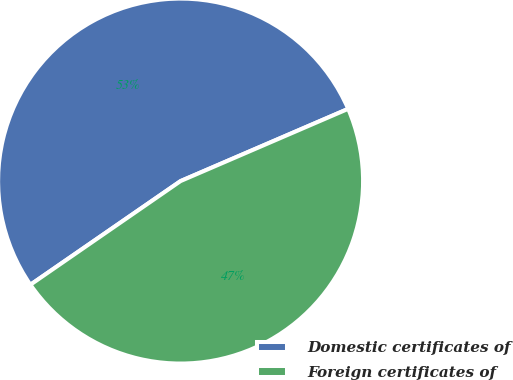Convert chart to OTSL. <chart><loc_0><loc_0><loc_500><loc_500><pie_chart><fcel>Domestic certificates of<fcel>Foreign certificates of<nl><fcel>53.14%<fcel>46.86%<nl></chart> 